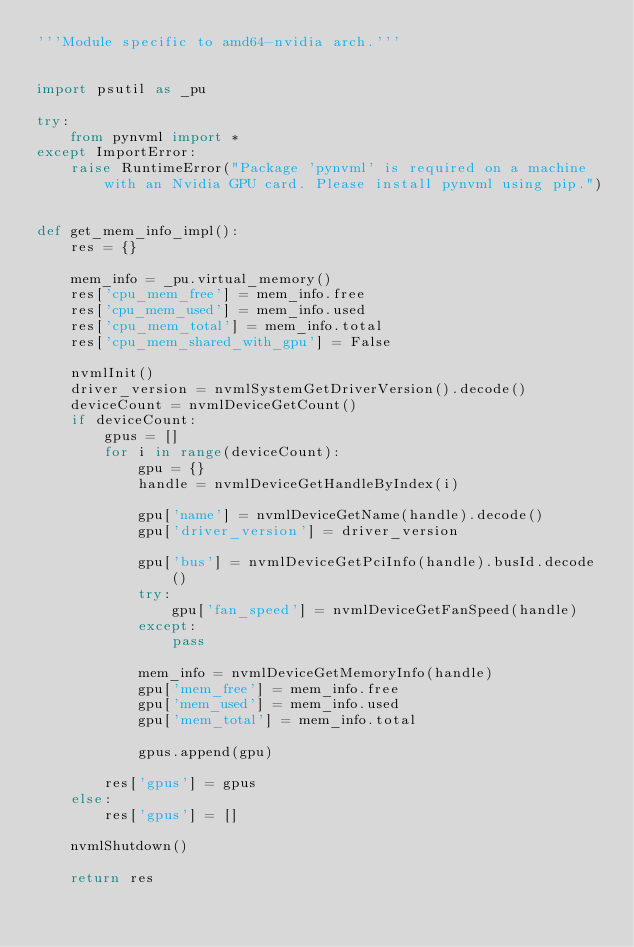<code> <loc_0><loc_0><loc_500><loc_500><_Python_>'''Module specific to amd64-nvidia arch.'''


import psutil as _pu

try:
    from pynvml import *
except ImportError:
    raise RuntimeError("Package 'pynvml' is required on a machine with an Nvidia GPU card. Please install pynvml using pip.")


def get_mem_info_impl():
    res = {}

    mem_info = _pu.virtual_memory()
    res['cpu_mem_free'] = mem_info.free
    res['cpu_mem_used'] = mem_info.used
    res['cpu_mem_total'] = mem_info.total
    res['cpu_mem_shared_with_gpu'] = False

    nvmlInit()
    driver_version = nvmlSystemGetDriverVersion().decode()
    deviceCount = nvmlDeviceGetCount()
    if deviceCount:
        gpus = []
        for i in range(deviceCount):
            gpu = {}
            handle = nvmlDeviceGetHandleByIndex(i)
            
            gpu['name'] = nvmlDeviceGetName(handle).decode()
            gpu['driver_version'] = driver_version

            gpu['bus'] = nvmlDeviceGetPciInfo(handle).busId.decode()
            try:
                gpu['fan_speed'] = nvmlDeviceGetFanSpeed(handle)
            except:
                pass

            mem_info = nvmlDeviceGetMemoryInfo(handle)
            gpu['mem_free'] = mem_info.free
            gpu['mem_used'] = mem_info.used
            gpu['mem_total'] = mem_info.total

            gpus.append(gpu)

        res['gpus'] = gpus
    else:
        res['gpus'] = []

    nvmlShutdown()

    return res
</code> 